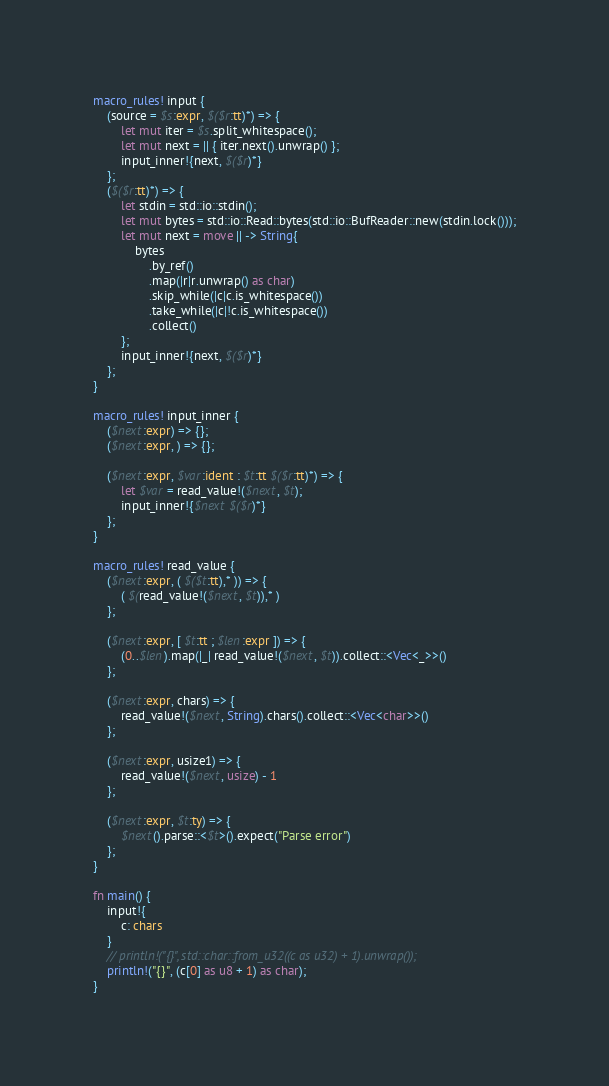<code> <loc_0><loc_0><loc_500><loc_500><_Rust_>macro_rules! input {
    (source = $s:expr, $($r:tt)*) => {
        let mut iter = $s.split_whitespace();
        let mut next = || { iter.next().unwrap() };
        input_inner!{next, $($r)*}
    };
    ($($r:tt)*) => {
        let stdin = std::io::stdin();
        let mut bytes = std::io::Read::bytes(std::io::BufReader::new(stdin.lock()));
        let mut next = move || -> String{
            bytes
                .by_ref()
                .map(|r|r.unwrap() as char)
                .skip_while(|c|c.is_whitespace())
                .take_while(|c|!c.is_whitespace())
                .collect()
        };
        input_inner!{next, $($r)*}
    };
}

macro_rules! input_inner {
    ($next:expr) => {};
    ($next:expr, ) => {};

    ($next:expr, $var:ident : $t:tt $($r:tt)*) => {
        let $var = read_value!($next, $t);
        input_inner!{$next $($r)*}
    };
}

macro_rules! read_value {
    ($next:expr, ( $($t:tt),* )) => {
        ( $(read_value!($next, $t)),* )
    };

    ($next:expr, [ $t:tt ; $len:expr ]) => {
        (0..$len).map(|_| read_value!($next, $t)).collect::<Vec<_>>()
    };

    ($next:expr, chars) => {
        read_value!($next, String).chars().collect::<Vec<char>>()
    };

    ($next:expr, usize1) => {
        read_value!($next, usize) - 1
    };

    ($next:expr, $t:ty) => {
        $next().parse::<$t>().expect("Parse error")
    };
}

fn main() {
    input!{
        c: chars
    }
    // println!("{}", std::char::from_u32((c as u32) + 1).unwrap());
    println!("{}", (c[0] as u8 + 1) as char);
}
</code> 